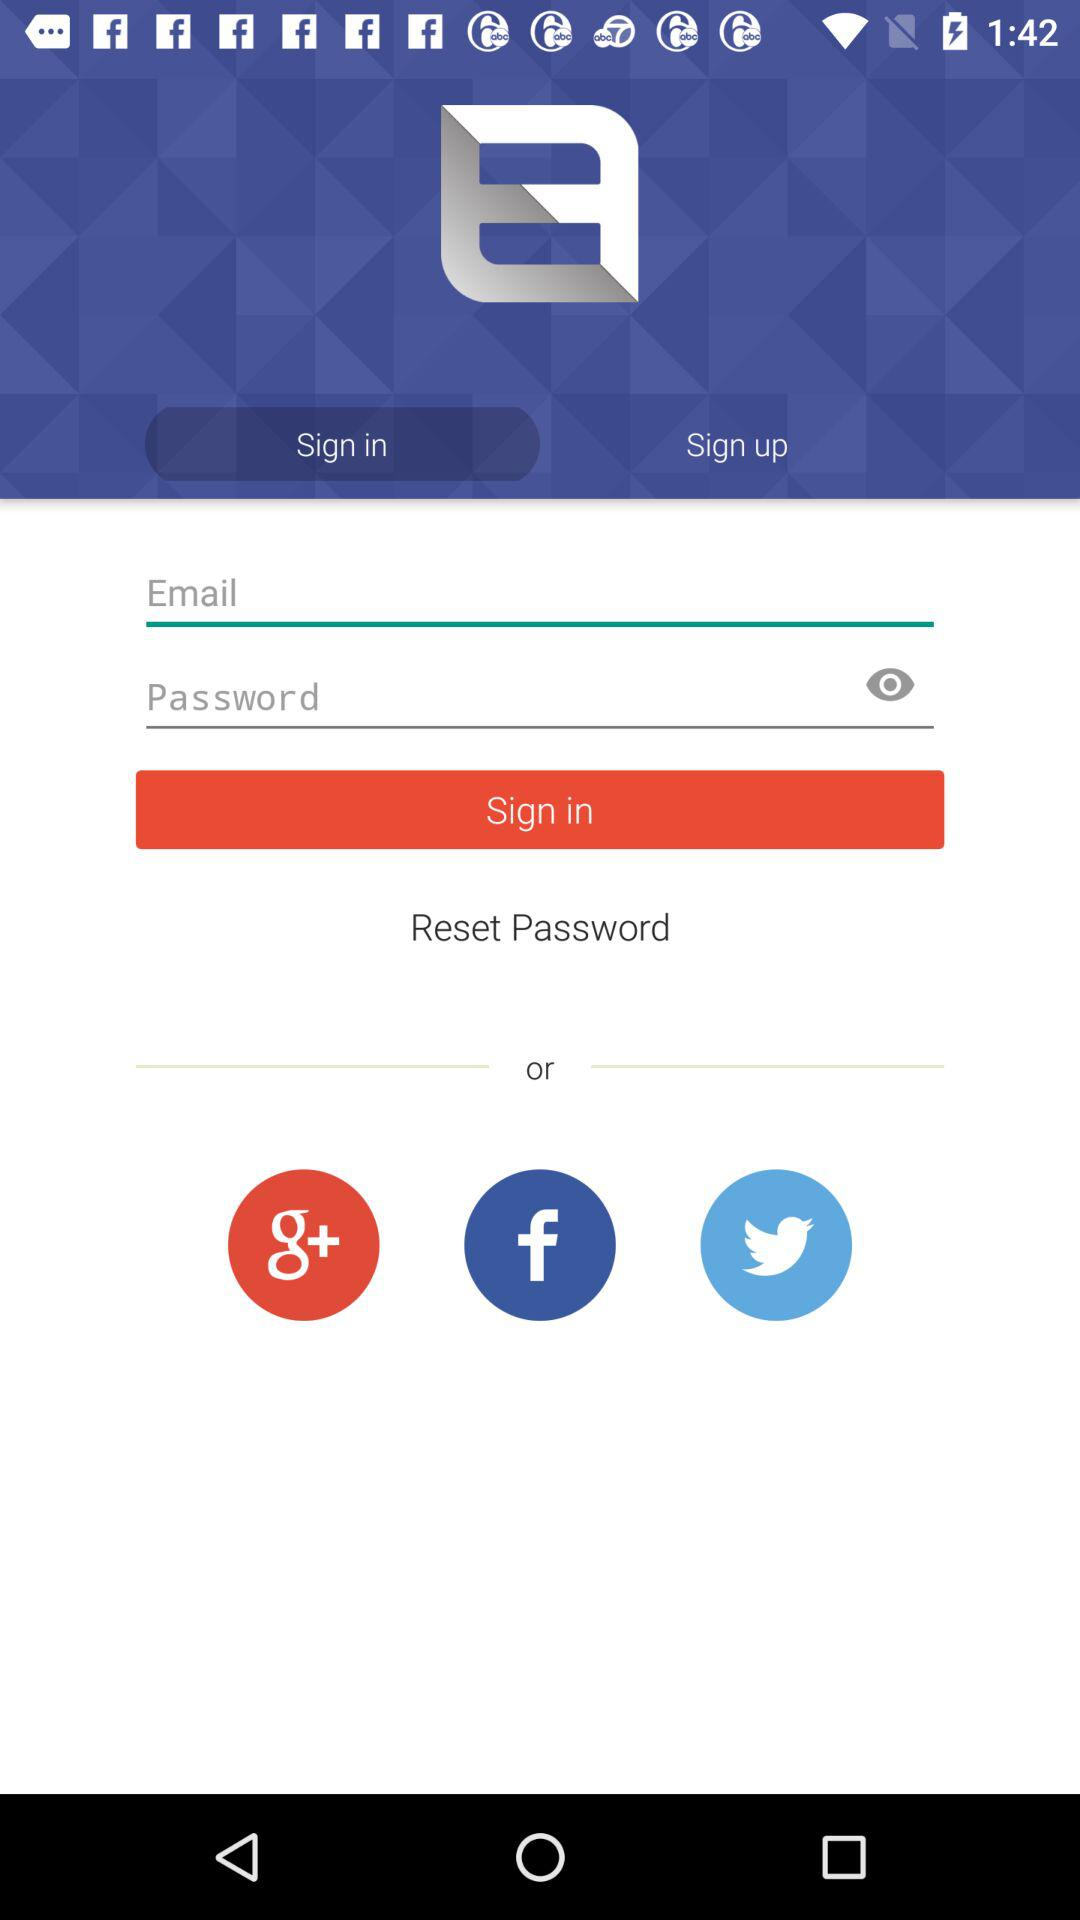What are the requirements to login? The requirements to log in are an email and a password. 